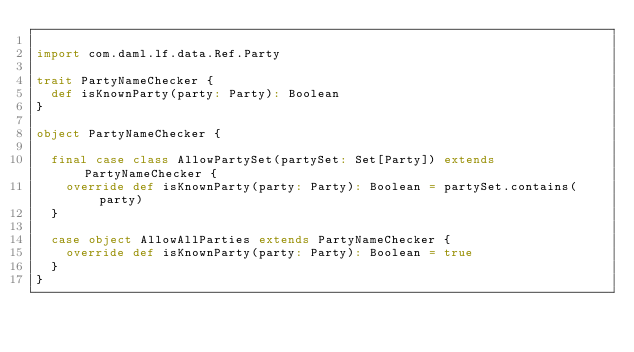<code> <loc_0><loc_0><loc_500><loc_500><_Scala_>
import com.daml.lf.data.Ref.Party

trait PartyNameChecker {
  def isKnownParty(party: Party): Boolean
}

object PartyNameChecker {

  final case class AllowPartySet(partySet: Set[Party]) extends PartyNameChecker {
    override def isKnownParty(party: Party): Boolean = partySet.contains(party)
  }

  case object AllowAllParties extends PartyNameChecker {
    override def isKnownParty(party: Party): Boolean = true
  }
}
</code> 